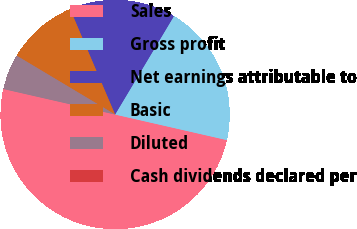<chart> <loc_0><loc_0><loc_500><loc_500><pie_chart><fcel>Sales<fcel>Gross profit<fcel>Net earnings attributable to<fcel>Basic<fcel>Diluted<fcel>Cash dividends declared per<nl><fcel>50.0%<fcel>20.0%<fcel>15.0%<fcel>10.0%<fcel>5.0%<fcel>0.0%<nl></chart> 